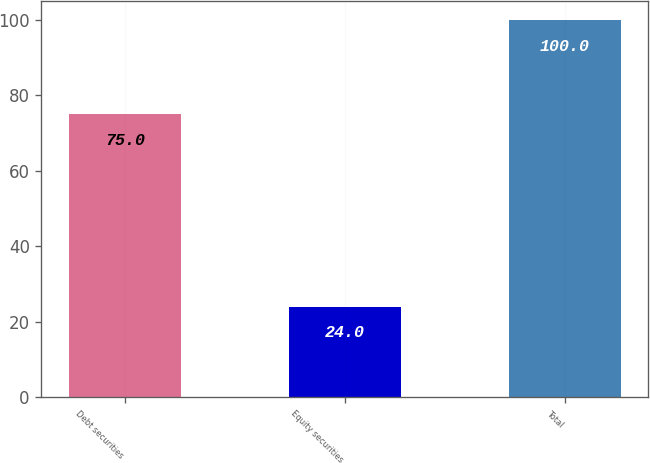Convert chart to OTSL. <chart><loc_0><loc_0><loc_500><loc_500><bar_chart><fcel>Debt securities<fcel>Equity securities<fcel>Total<nl><fcel>75<fcel>24<fcel>100<nl></chart> 